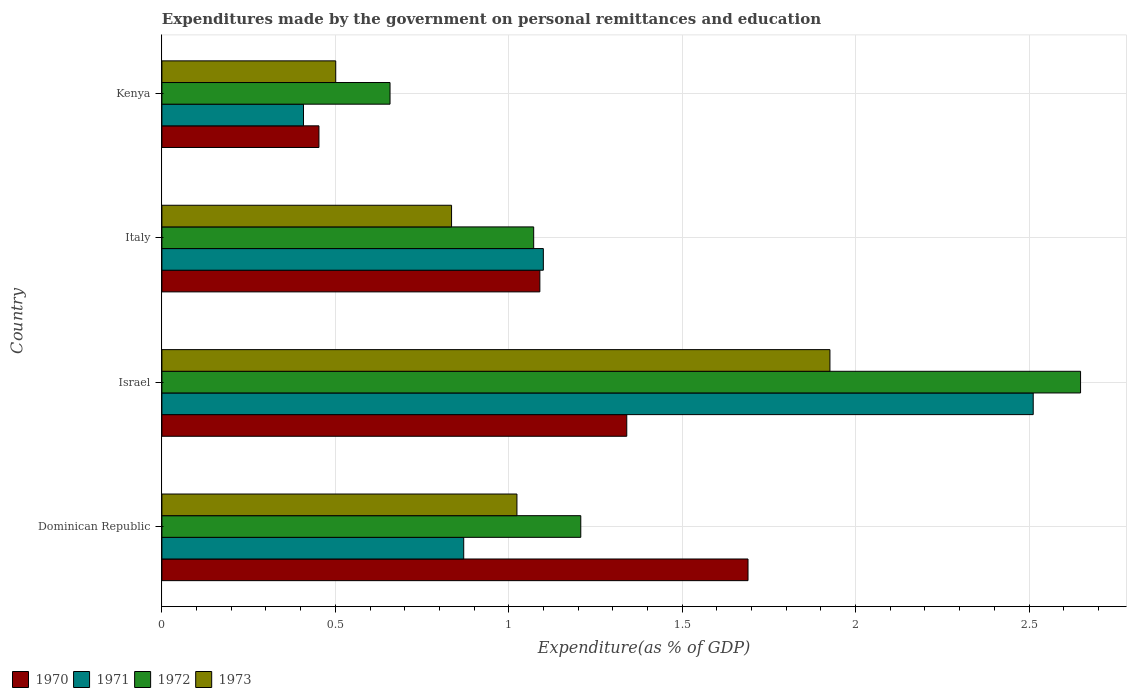How many groups of bars are there?
Keep it short and to the point. 4. Are the number of bars on each tick of the Y-axis equal?
Your response must be concise. Yes. How many bars are there on the 3rd tick from the top?
Offer a terse response. 4. What is the label of the 3rd group of bars from the top?
Provide a succinct answer. Israel. In how many cases, is the number of bars for a given country not equal to the number of legend labels?
Keep it short and to the point. 0. What is the expenditures made by the government on personal remittances and education in 1970 in Dominican Republic?
Give a very brief answer. 1.69. Across all countries, what is the maximum expenditures made by the government on personal remittances and education in 1971?
Your answer should be compact. 2.51. Across all countries, what is the minimum expenditures made by the government on personal remittances and education in 1970?
Offer a very short reply. 0.45. In which country was the expenditures made by the government on personal remittances and education in 1971 minimum?
Your answer should be very brief. Kenya. What is the total expenditures made by the government on personal remittances and education in 1973 in the graph?
Provide a short and direct response. 4.29. What is the difference between the expenditures made by the government on personal remittances and education in 1970 in Dominican Republic and that in Israel?
Ensure brevity in your answer.  0.35. What is the difference between the expenditures made by the government on personal remittances and education in 1971 in Italy and the expenditures made by the government on personal remittances and education in 1970 in Kenya?
Ensure brevity in your answer.  0.65. What is the average expenditures made by the government on personal remittances and education in 1972 per country?
Keep it short and to the point. 1.4. What is the difference between the expenditures made by the government on personal remittances and education in 1970 and expenditures made by the government on personal remittances and education in 1971 in Italy?
Make the answer very short. -0.01. In how many countries, is the expenditures made by the government on personal remittances and education in 1972 greater than 1.5 %?
Give a very brief answer. 1. What is the ratio of the expenditures made by the government on personal remittances and education in 1970 in Israel to that in Italy?
Provide a succinct answer. 1.23. Is the difference between the expenditures made by the government on personal remittances and education in 1970 in Dominican Republic and Israel greater than the difference between the expenditures made by the government on personal remittances and education in 1971 in Dominican Republic and Israel?
Your answer should be very brief. Yes. What is the difference between the highest and the second highest expenditures made by the government on personal remittances and education in 1971?
Provide a succinct answer. 1.41. What is the difference between the highest and the lowest expenditures made by the government on personal remittances and education in 1972?
Offer a terse response. 1.99. In how many countries, is the expenditures made by the government on personal remittances and education in 1970 greater than the average expenditures made by the government on personal remittances and education in 1970 taken over all countries?
Your answer should be compact. 2. Is the sum of the expenditures made by the government on personal remittances and education in 1973 in Israel and Kenya greater than the maximum expenditures made by the government on personal remittances and education in 1972 across all countries?
Make the answer very short. No. How many bars are there?
Make the answer very short. 16. Are all the bars in the graph horizontal?
Offer a terse response. Yes. What is the difference between two consecutive major ticks on the X-axis?
Your answer should be very brief. 0.5. Are the values on the major ticks of X-axis written in scientific E-notation?
Give a very brief answer. No. Does the graph contain any zero values?
Offer a very short reply. No. Does the graph contain grids?
Offer a terse response. Yes. How are the legend labels stacked?
Your answer should be compact. Horizontal. What is the title of the graph?
Your answer should be very brief. Expenditures made by the government on personal remittances and education. Does "1992" appear as one of the legend labels in the graph?
Your answer should be compact. No. What is the label or title of the X-axis?
Offer a terse response. Expenditure(as % of GDP). What is the Expenditure(as % of GDP) in 1970 in Dominican Republic?
Offer a terse response. 1.69. What is the Expenditure(as % of GDP) of 1971 in Dominican Republic?
Keep it short and to the point. 0.87. What is the Expenditure(as % of GDP) in 1972 in Dominican Republic?
Provide a short and direct response. 1.21. What is the Expenditure(as % of GDP) in 1973 in Dominican Republic?
Give a very brief answer. 1.02. What is the Expenditure(as % of GDP) of 1970 in Israel?
Give a very brief answer. 1.34. What is the Expenditure(as % of GDP) in 1971 in Israel?
Ensure brevity in your answer.  2.51. What is the Expenditure(as % of GDP) in 1972 in Israel?
Offer a terse response. 2.65. What is the Expenditure(as % of GDP) of 1973 in Israel?
Give a very brief answer. 1.93. What is the Expenditure(as % of GDP) in 1970 in Italy?
Keep it short and to the point. 1.09. What is the Expenditure(as % of GDP) in 1971 in Italy?
Keep it short and to the point. 1.1. What is the Expenditure(as % of GDP) in 1972 in Italy?
Your response must be concise. 1.07. What is the Expenditure(as % of GDP) of 1973 in Italy?
Provide a succinct answer. 0.84. What is the Expenditure(as % of GDP) in 1970 in Kenya?
Your answer should be compact. 0.45. What is the Expenditure(as % of GDP) of 1971 in Kenya?
Offer a very short reply. 0.41. What is the Expenditure(as % of GDP) in 1972 in Kenya?
Give a very brief answer. 0.66. What is the Expenditure(as % of GDP) in 1973 in Kenya?
Keep it short and to the point. 0.5. Across all countries, what is the maximum Expenditure(as % of GDP) in 1970?
Give a very brief answer. 1.69. Across all countries, what is the maximum Expenditure(as % of GDP) of 1971?
Give a very brief answer. 2.51. Across all countries, what is the maximum Expenditure(as % of GDP) of 1972?
Offer a terse response. 2.65. Across all countries, what is the maximum Expenditure(as % of GDP) in 1973?
Provide a succinct answer. 1.93. Across all countries, what is the minimum Expenditure(as % of GDP) in 1970?
Provide a short and direct response. 0.45. Across all countries, what is the minimum Expenditure(as % of GDP) in 1971?
Provide a short and direct response. 0.41. Across all countries, what is the minimum Expenditure(as % of GDP) in 1972?
Provide a short and direct response. 0.66. Across all countries, what is the minimum Expenditure(as % of GDP) of 1973?
Keep it short and to the point. 0.5. What is the total Expenditure(as % of GDP) of 1970 in the graph?
Provide a succinct answer. 4.57. What is the total Expenditure(as % of GDP) in 1971 in the graph?
Provide a succinct answer. 4.89. What is the total Expenditure(as % of GDP) of 1972 in the graph?
Your answer should be compact. 5.59. What is the total Expenditure(as % of GDP) in 1973 in the graph?
Offer a very short reply. 4.29. What is the difference between the Expenditure(as % of GDP) of 1970 in Dominican Republic and that in Israel?
Your answer should be very brief. 0.35. What is the difference between the Expenditure(as % of GDP) of 1971 in Dominican Republic and that in Israel?
Provide a succinct answer. -1.64. What is the difference between the Expenditure(as % of GDP) of 1972 in Dominican Republic and that in Israel?
Give a very brief answer. -1.44. What is the difference between the Expenditure(as % of GDP) of 1973 in Dominican Republic and that in Israel?
Provide a short and direct response. -0.9. What is the difference between the Expenditure(as % of GDP) in 1970 in Dominican Republic and that in Italy?
Offer a very short reply. 0.6. What is the difference between the Expenditure(as % of GDP) of 1971 in Dominican Republic and that in Italy?
Offer a very short reply. -0.23. What is the difference between the Expenditure(as % of GDP) of 1972 in Dominican Republic and that in Italy?
Give a very brief answer. 0.14. What is the difference between the Expenditure(as % of GDP) in 1973 in Dominican Republic and that in Italy?
Make the answer very short. 0.19. What is the difference between the Expenditure(as % of GDP) in 1970 in Dominican Republic and that in Kenya?
Keep it short and to the point. 1.24. What is the difference between the Expenditure(as % of GDP) in 1971 in Dominican Republic and that in Kenya?
Ensure brevity in your answer.  0.46. What is the difference between the Expenditure(as % of GDP) in 1972 in Dominican Republic and that in Kenya?
Your response must be concise. 0.55. What is the difference between the Expenditure(as % of GDP) of 1973 in Dominican Republic and that in Kenya?
Your answer should be very brief. 0.52. What is the difference between the Expenditure(as % of GDP) in 1970 in Israel and that in Italy?
Keep it short and to the point. 0.25. What is the difference between the Expenditure(as % of GDP) of 1971 in Israel and that in Italy?
Provide a succinct answer. 1.41. What is the difference between the Expenditure(as % of GDP) of 1972 in Israel and that in Italy?
Provide a succinct answer. 1.58. What is the difference between the Expenditure(as % of GDP) in 1973 in Israel and that in Italy?
Ensure brevity in your answer.  1.09. What is the difference between the Expenditure(as % of GDP) in 1970 in Israel and that in Kenya?
Offer a terse response. 0.89. What is the difference between the Expenditure(as % of GDP) in 1971 in Israel and that in Kenya?
Your answer should be compact. 2.1. What is the difference between the Expenditure(as % of GDP) in 1972 in Israel and that in Kenya?
Your response must be concise. 1.99. What is the difference between the Expenditure(as % of GDP) in 1973 in Israel and that in Kenya?
Keep it short and to the point. 1.42. What is the difference between the Expenditure(as % of GDP) in 1970 in Italy and that in Kenya?
Keep it short and to the point. 0.64. What is the difference between the Expenditure(as % of GDP) in 1971 in Italy and that in Kenya?
Provide a short and direct response. 0.69. What is the difference between the Expenditure(as % of GDP) in 1972 in Italy and that in Kenya?
Keep it short and to the point. 0.41. What is the difference between the Expenditure(as % of GDP) in 1973 in Italy and that in Kenya?
Keep it short and to the point. 0.33. What is the difference between the Expenditure(as % of GDP) in 1970 in Dominican Republic and the Expenditure(as % of GDP) in 1971 in Israel?
Ensure brevity in your answer.  -0.82. What is the difference between the Expenditure(as % of GDP) in 1970 in Dominican Republic and the Expenditure(as % of GDP) in 1972 in Israel?
Keep it short and to the point. -0.96. What is the difference between the Expenditure(as % of GDP) in 1970 in Dominican Republic and the Expenditure(as % of GDP) in 1973 in Israel?
Your answer should be compact. -0.24. What is the difference between the Expenditure(as % of GDP) of 1971 in Dominican Republic and the Expenditure(as % of GDP) of 1972 in Israel?
Provide a succinct answer. -1.78. What is the difference between the Expenditure(as % of GDP) of 1971 in Dominican Republic and the Expenditure(as % of GDP) of 1973 in Israel?
Offer a very short reply. -1.06. What is the difference between the Expenditure(as % of GDP) of 1972 in Dominican Republic and the Expenditure(as % of GDP) of 1973 in Israel?
Give a very brief answer. -0.72. What is the difference between the Expenditure(as % of GDP) in 1970 in Dominican Republic and the Expenditure(as % of GDP) in 1971 in Italy?
Your response must be concise. 0.59. What is the difference between the Expenditure(as % of GDP) of 1970 in Dominican Republic and the Expenditure(as % of GDP) of 1972 in Italy?
Offer a very short reply. 0.62. What is the difference between the Expenditure(as % of GDP) in 1970 in Dominican Republic and the Expenditure(as % of GDP) in 1973 in Italy?
Provide a short and direct response. 0.85. What is the difference between the Expenditure(as % of GDP) in 1971 in Dominican Republic and the Expenditure(as % of GDP) in 1972 in Italy?
Your response must be concise. -0.2. What is the difference between the Expenditure(as % of GDP) in 1971 in Dominican Republic and the Expenditure(as % of GDP) in 1973 in Italy?
Give a very brief answer. 0.04. What is the difference between the Expenditure(as % of GDP) of 1972 in Dominican Republic and the Expenditure(as % of GDP) of 1973 in Italy?
Provide a succinct answer. 0.37. What is the difference between the Expenditure(as % of GDP) of 1970 in Dominican Republic and the Expenditure(as % of GDP) of 1971 in Kenya?
Make the answer very short. 1.28. What is the difference between the Expenditure(as % of GDP) in 1970 in Dominican Republic and the Expenditure(as % of GDP) in 1972 in Kenya?
Make the answer very short. 1.03. What is the difference between the Expenditure(as % of GDP) in 1970 in Dominican Republic and the Expenditure(as % of GDP) in 1973 in Kenya?
Provide a short and direct response. 1.19. What is the difference between the Expenditure(as % of GDP) in 1971 in Dominican Republic and the Expenditure(as % of GDP) in 1972 in Kenya?
Offer a very short reply. 0.21. What is the difference between the Expenditure(as % of GDP) in 1971 in Dominican Republic and the Expenditure(as % of GDP) in 1973 in Kenya?
Your answer should be very brief. 0.37. What is the difference between the Expenditure(as % of GDP) in 1972 in Dominican Republic and the Expenditure(as % of GDP) in 1973 in Kenya?
Your response must be concise. 0.71. What is the difference between the Expenditure(as % of GDP) of 1970 in Israel and the Expenditure(as % of GDP) of 1971 in Italy?
Your response must be concise. 0.24. What is the difference between the Expenditure(as % of GDP) of 1970 in Israel and the Expenditure(as % of GDP) of 1972 in Italy?
Provide a short and direct response. 0.27. What is the difference between the Expenditure(as % of GDP) in 1970 in Israel and the Expenditure(as % of GDP) in 1973 in Italy?
Your answer should be very brief. 0.51. What is the difference between the Expenditure(as % of GDP) of 1971 in Israel and the Expenditure(as % of GDP) of 1972 in Italy?
Provide a short and direct response. 1.44. What is the difference between the Expenditure(as % of GDP) in 1971 in Israel and the Expenditure(as % of GDP) in 1973 in Italy?
Offer a terse response. 1.68. What is the difference between the Expenditure(as % of GDP) of 1972 in Israel and the Expenditure(as % of GDP) of 1973 in Italy?
Your response must be concise. 1.81. What is the difference between the Expenditure(as % of GDP) of 1970 in Israel and the Expenditure(as % of GDP) of 1971 in Kenya?
Offer a terse response. 0.93. What is the difference between the Expenditure(as % of GDP) in 1970 in Israel and the Expenditure(as % of GDP) in 1972 in Kenya?
Your answer should be very brief. 0.68. What is the difference between the Expenditure(as % of GDP) in 1970 in Israel and the Expenditure(as % of GDP) in 1973 in Kenya?
Your response must be concise. 0.84. What is the difference between the Expenditure(as % of GDP) of 1971 in Israel and the Expenditure(as % of GDP) of 1972 in Kenya?
Provide a short and direct response. 1.85. What is the difference between the Expenditure(as % of GDP) of 1971 in Israel and the Expenditure(as % of GDP) of 1973 in Kenya?
Keep it short and to the point. 2.01. What is the difference between the Expenditure(as % of GDP) of 1972 in Israel and the Expenditure(as % of GDP) of 1973 in Kenya?
Make the answer very short. 2.15. What is the difference between the Expenditure(as % of GDP) in 1970 in Italy and the Expenditure(as % of GDP) in 1971 in Kenya?
Your answer should be very brief. 0.68. What is the difference between the Expenditure(as % of GDP) in 1970 in Italy and the Expenditure(as % of GDP) in 1972 in Kenya?
Provide a short and direct response. 0.43. What is the difference between the Expenditure(as % of GDP) in 1970 in Italy and the Expenditure(as % of GDP) in 1973 in Kenya?
Ensure brevity in your answer.  0.59. What is the difference between the Expenditure(as % of GDP) in 1971 in Italy and the Expenditure(as % of GDP) in 1972 in Kenya?
Keep it short and to the point. 0.44. What is the difference between the Expenditure(as % of GDP) of 1971 in Italy and the Expenditure(as % of GDP) of 1973 in Kenya?
Offer a very short reply. 0.6. What is the difference between the Expenditure(as % of GDP) of 1972 in Italy and the Expenditure(as % of GDP) of 1973 in Kenya?
Your response must be concise. 0.57. What is the average Expenditure(as % of GDP) in 1970 per country?
Offer a terse response. 1.14. What is the average Expenditure(as % of GDP) in 1971 per country?
Offer a very short reply. 1.22. What is the average Expenditure(as % of GDP) of 1972 per country?
Your answer should be very brief. 1.4. What is the average Expenditure(as % of GDP) in 1973 per country?
Offer a terse response. 1.07. What is the difference between the Expenditure(as % of GDP) of 1970 and Expenditure(as % of GDP) of 1971 in Dominican Republic?
Keep it short and to the point. 0.82. What is the difference between the Expenditure(as % of GDP) in 1970 and Expenditure(as % of GDP) in 1972 in Dominican Republic?
Your response must be concise. 0.48. What is the difference between the Expenditure(as % of GDP) of 1970 and Expenditure(as % of GDP) of 1973 in Dominican Republic?
Your answer should be very brief. 0.67. What is the difference between the Expenditure(as % of GDP) of 1971 and Expenditure(as % of GDP) of 1972 in Dominican Republic?
Make the answer very short. -0.34. What is the difference between the Expenditure(as % of GDP) of 1971 and Expenditure(as % of GDP) of 1973 in Dominican Republic?
Keep it short and to the point. -0.15. What is the difference between the Expenditure(as % of GDP) in 1972 and Expenditure(as % of GDP) in 1973 in Dominican Republic?
Your response must be concise. 0.18. What is the difference between the Expenditure(as % of GDP) in 1970 and Expenditure(as % of GDP) in 1971 in Israel?
Your answer should be compact. -1.17. What is the difference between the Expenditure(as % of GDP) in 1970 and Expenditure(as % of GDP) in 1972 in Israel?
Give a very brief answer. -1.31. What is the difference between the Expenditure(as % of GDP) in 1970 and Expenditure(as % of GDP) in 1973 in Israel?
Your answer should be very brief. -0.59. What is the difference between the Expenditure(as % of GDP) of 1971 and Expenditure(as % of GDP) of 1972 in Israel?
Offer a terse response. -0.14. What is the difference between the Expenditure(as % of GDP) in 1971 and Expenditure(as % of GDP) in 1973 in Israel?
Provide a short and direct response. 0.59. What is the difference between the Expenditure(as % of GDP) in 1972 and Expenditure(as % of GDP) in 1973 in Israel?
Your response must be concise. 0.72. What is the difference between the Expenditure(as % of GDP) in 1970 and Expenditure(as % of GDP) in 1971 in Italy?
Keep it short and to the point. -0.01. What is the difference between the Expenditure(as % of GDP) in 1970 and Expenditure(as % of GDP) in 1972 in Italy?
Make the answer very short. 0.02. What is the difference between the Expenditure(as % of GDP) of 1970 and Expenditure(as % of GDP) of 1973 in Italy?
Your answer should be very brief. 0.25. What is the difference between the Expenditure(as % of GDP) of 1971 and Expenditure(as % of GDP) of 1972 in Italy?
Provide a short and direct response. 0.03. What is the difference between the Expenditure(as % of GDP) of 1971 and Expenditure(as % of GDP) of 1973 in Italy?
Provide a succinct answer. 0.26. What is the difference between the Expenditure(as % of GDP) of 1972 and Expenditure(as % of GDP) of 1973 in Italy?
Your answer should be very brief. 0.24. What is the difference between the Expenditure(as % of GDP) in 1970 and Expenditure(as % of GDP) in 1971 in Kenya?
Provide a succinct answer. 0.04. What is the difference between the Expenditure(as % of GDP) in 1970 and Expenditure(as % of GDP) in 1972 in Kenya?
Ensure brevity in your answer.  -0.2. What is the difference between the Expenditure(as % of GDP) of 1970 and Expenditure(as % of GDP) of 1973 in Kenya?
Your answer should be compact. -0.05. What is the difference between the Expenditure(as % of GDP) in 1971 and Expenditure(as % of GDP) in 1972 in Kenya?
Offer a terse response. -0.25. What is the difference between the Expenditure(as % of GDP) in 1971 and Expenditure(as % of GDP) in 1973 in Kenya?
Ensure brevity in your answer.  -0.09. What is the difference between the Expenditure(as % of GDP) in 1972 and Expenditure(as % of GDP) in 1973 in Kenya?
Offer a very short reply. 0.16. What is the ratio of the Expenditure(as % of GDP) of 1970 in Dominican Republic to that in Israel?
Offer a terse response. 1.26. What is the ratio of the Expenditure(as % of GDP) in 1971 in Dominican Republic to that in Israel?
Your response must be concise. 0.35. What is the ratio of the Expenditure(as % of GDP) in 1972 in Dominican Republic to that in Israel?
Ensure brevity in your answer.  0.46. What is the ratio of the Expenditure(as % of GDP) of 1973 in Dominican Republic to that in Israel?
Ensure brevity in your answer.  0.53. What is the ratio of the Expenditure(as % of GDP) of 1970 in Dominican Republic to that in Italy?
Your answer should be compact. 1.55. What is the ratio of the Expenditure(as % of GDP) in 1971 in Dominican Republic to that in Italy?
Your answer should be compact. 0.79. What is the ratio of the Expenditure(as % of GDP) in 1972 in Dominican Republic to that in Italy?
Provide a succinct answer. 1.13. What is the ratio of the Expenditure(as % of GDP) in 1973 in Dominican Republic to that in Italy?
Provide a succinct answer. 1.23. What is the ratio of the Expenditure(as % of GDP) of 1970 in Dominican Republic to that in Kenya?
Provide a short and direct response. 3.73. What is the ratio of the Expenditure(as % of GDP) in 1971 in Dominican Republic to that in Kenya?
Offer a very short reply. 2.13. What is the ratio of the Expenditure(as % of GDP) in 1972 in Dominican Republic to that in Kenya?
Your answer should be compact. 1.84. What is the ratio of the Expenditure(as % of GDP) of 1973 in Dominican Republic to that in Kenya?
Offer a very short reply. 2.04. What is the ratio of the Expenditure(as % of GDP) of 1970 in Israel to that in Italy?
Provide a short and direct response. 1.23. What is the ratio of the Expenditure(as % of GDP) of 1971 in Israel to that in Italy?
Your answer should be very brief. 2.28. What is the ratio of the Expenditure(as % of GDP) of 1972 in Israel to that in Italy?
Make the answer very short. 2.47. What is the ratio of the Expenditure(as % of GDP) of 1973 in Israel to that in Italy?
Your answer should be very brief. 2.31. What is the ratio of the Expenditure(as % of GDP) of 1970 in Israel to that in Kenya?
Give a very brief answer. 2.96. What is the ratio of the Expenditure(as % of GDP) in 1971 in Israel to that in Kenya?
Provide a succinct answer. 6.15. What is the ratio of the Expenditure(as % of GDP) in 1972 in Israel to that in Kenya?
Offer a very short reply. 4.03. What is the ratio of the Expenditure(as % of GDP) of 1973 in Israel to that in Kenya?
Offer a terse response. 3.84. What is the ratio of the Expenditure(as % of GDP) in 1970 in Italy to that in Kenya?
Your answer should be compact. 2.41. What is the ratio of the Expenditure(as % of GDP) in 1971 in Italy to that in Kenya?
Offer a very short reply. 2.69. What is the ratio of the Expenditure(as % of GDP) in 1972 in Italy to that in Kenya?
Offer a very short reply. 1.63. What is the ratio of the Expenditure(as % of GDP) of 1973 in Italy to that in Kenya?
Keep it short and to the point. 1.67. What is the difference between the highest and the second highest Expenditure(as % of GDP) in 1970?
Offer a very short reply. 0.35. What is the difference between the highest and the second highest Expenditure(as % of GDP) of 1971?
Provide a short and direct response. 1.41. What is the difference between the highest and the second highest Expenditure(as % of GDP) in 1972?
Your response must be concise. 1.44. What is the difference between the highest and the second highest Expenditure(as % of GDP) in 1973?
Provide a short and direct response. 0.9. What is the difference between the highest and the lowest Expenditure(as % of GDP) in 1970?
Keep it short and to the point. 1.24. What is the difference between the highest and the lowest Expenditure(as % of GDP) in 1971?
Keep it short and to the point. 2.1. What is the difference between the highest and the lowest Expenditure(as % of GDP) of 1972?
Offer a terse response. 1.99. What is the difference between the highest and the lowest Expenditure(as % of GDP) in 1973?
Ensure brevity in your answer.  1.42. 